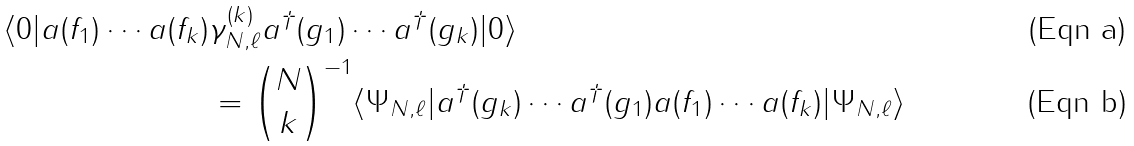<formula> <loc_0><loc_0><loc_500><loc_500>\langle 0 | a ( f _ { 1 } ) \cdots a ( f _ { k } ) & \gamma _ { N , \ell } ^ { ( k ) } a ^ { \dagger } ( g _ { 1 } ) \cdots a ^ { \dagger } ( g _ { k } ) | 0 \rangle \\ & = { N \choose k } ^ { - 1 } \langle \Psi _ { N , \ell } | a ^ { \dagger } ( g _ { k } ) \cdots a ^ { \dagger } ( g _ { 1 } ) a ( f _ { 1 } ) \cdots a ( f _ { k } ) | \Psi _ { N , \ell } \rangle</formula> 